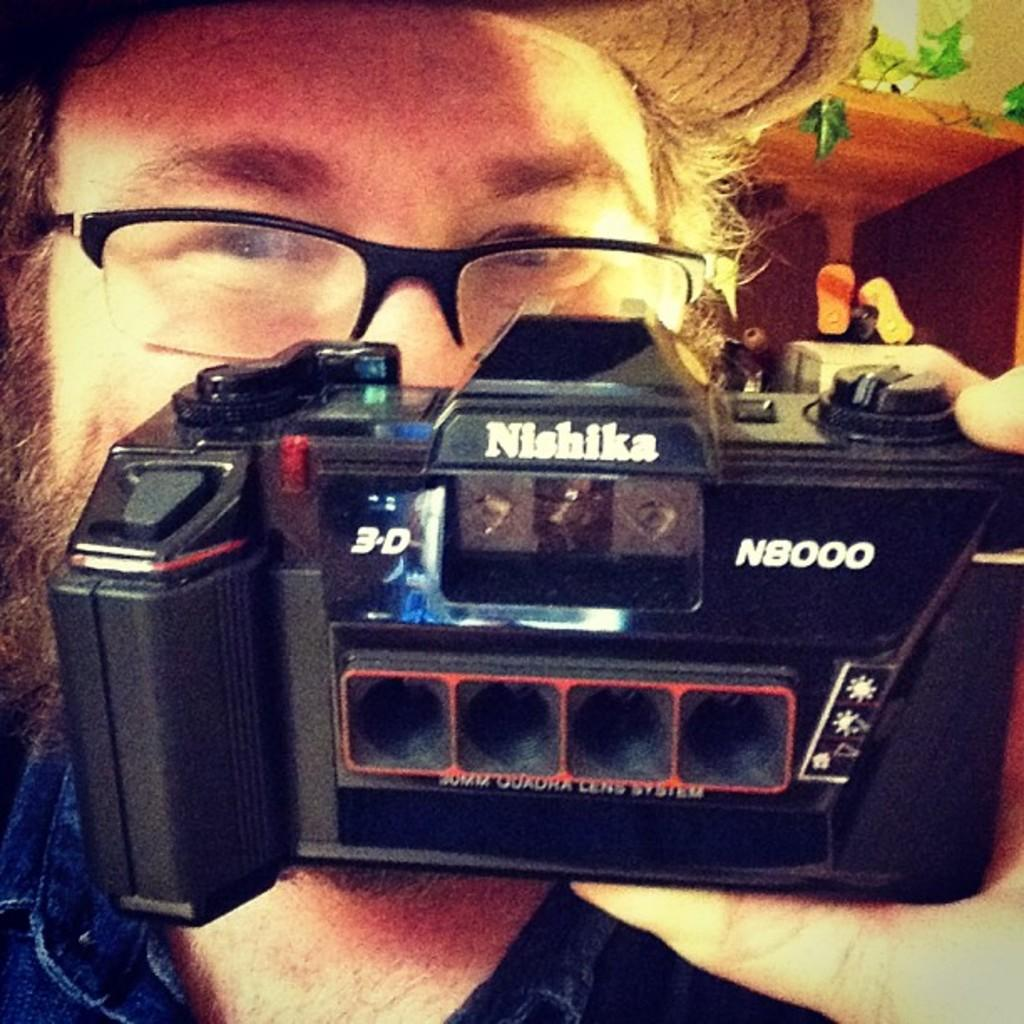What is the person in the image doing? The person is holding a camera in the image. What can be seen in the background of the image? There are leaves, stems, and other objects visible in the background of the image. What time is the meeting scheduled for in the image? There is no meeting or clock present in the image, so it is not possible to determine the time. 